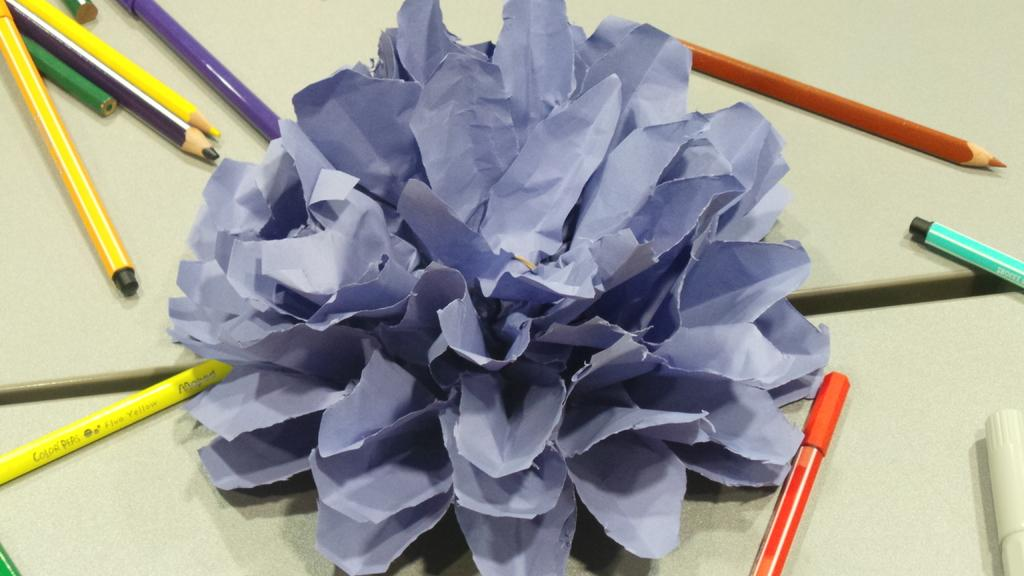What type of craft is visible in the image? There is a paper craft in the image. What writing instruments are present on the table? Pencils and pens are present on the table. What type of seed can be seen growing in the alley in the image? There is no alley or seed present in the image; it features a paper craft and writing instruments on a table. 